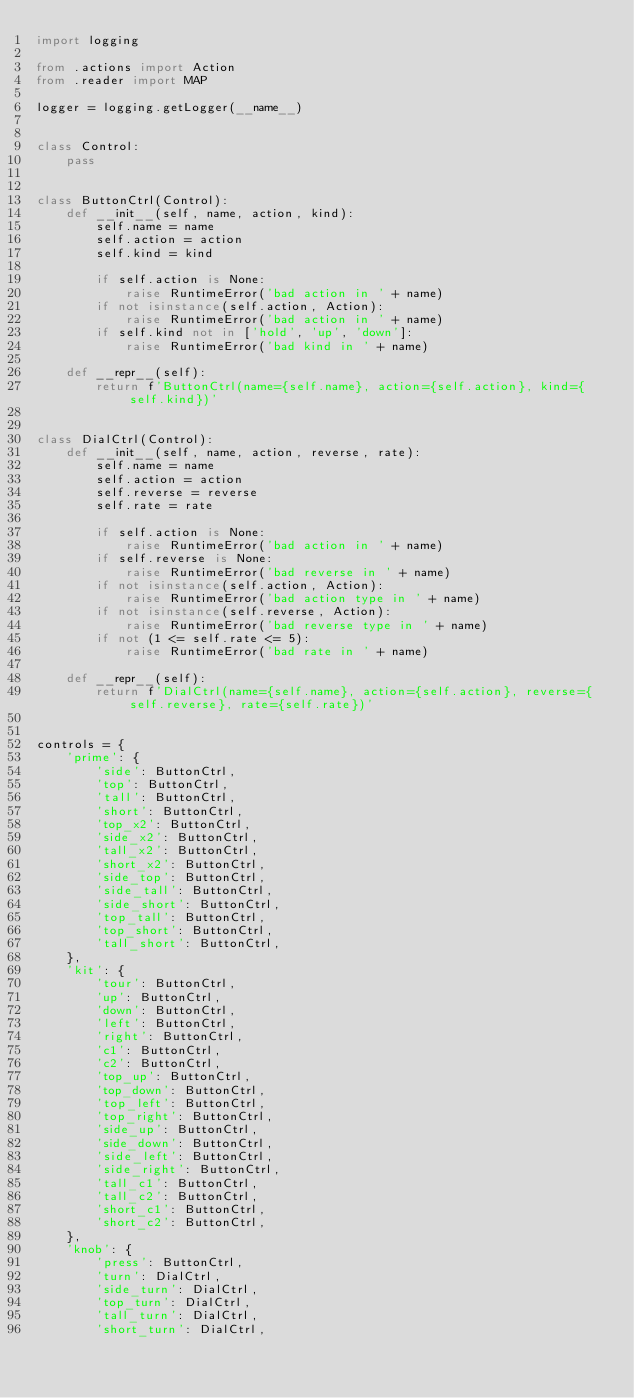Convert code to text. <code><loc_0><loc_0><loc_500><loc_500><_Python_>import logging

from .actions import Action
from .reader import MAP

logger = logging.getLogger(__name__)


class Control:
    pass


class ButtonCtrl(Control):
    def __init__(self, name, action, kind):
        self.name = name
        self.action = action
        self.kind = kind

        if self.action is None:
            raise RuntimeError('bad action in ' + name)
        if not isinstance(self.action, Action):
            raise RuntimeError('bad action in ' + name)
        if self.kind not in ['hold', 'up', 'down']:
            raise RuntimeError('bad kind in ' + name)

    def __repr__(self):
        return f'ButtonCtrl(name={self.name}, action={self.action}, kind={self.kind})'


class DialCtrl(Control):
    def __init__(self, name, action, reverse, rate):
        self.name = name
        self.action = action
        self.reverse = reverse
        self.rate = rate

        if self.action is None:
            raise RuntimeError('bad action in ' + name)
        if self.reverse is None:
            raise RuntimeError('bad reverse in ' + name)
        if not isinstance(self.action, Action):
            raise RuntimeError('bad action type in ' + name)
        if not isinstance(self.reverse, Action):
            raise RuntimeError('bad reverse type in ' + name)
        if not (1 <= self.rate <= 5):
            raise RuntimeError('bad rate in ' + name)

    def __repr__(self):
        return f'DialCtrl(name={self.name}, action={self.action}, reverse={self.reverse}, rate={self.rate})'


controls = {
    'prime': {
        'side': ButtonCtrl,
        'top': ButtonCtrl,
        'tall': ButtonCtrl,
        'short': ButtonCtrl,
        'top_x2': ButtonCtrl,
        'side_x2': ButtonCtrl,
        'tall_x2': ButtonCtrl,
        'short_x2': ButtonCtrl,
        'side_top': ButtonCtrl,
        'side_tall': ButtonCtrl,
        'side_short': ButtonCtrl,
        'top_tall': ButtonCtrl,
        'top_short': ButtonCtrl,
        'tall_short': ButtonCtrl,
    },
    'kit': {
        'tour': ButtonCtrl,
        'up': ButtonCtrl,
        'down': ButtonCtrl,
        'left': ButtonCtrl,
        'right': ButtonCtrl,
        'c1': ButtonCtrl,
        'c2': ButtonCtrl,
        'top_up': ButtonCtrl,
        'top_down': ButtonCtrl,
        'top_left': ButtonCtrl,
        'top_right': ButtonCtrl,
        'side_up': ButtonCtrl,
        'side_down': ButtonCtrl,
        'side_left': ButtonCtrl,
        'side_right': ButtonCtrl,
        'tall_c1': ButtonCtrl,
        'tall_c2': ButtonCtrl,
        'short_c1': ButtonCtrl,
        'short_c2': ButtonCtrl,
    },
    'knob': {
        'press': ButtonCtrl,
        'turn': DialCtrl,
        'side_turn': DialCtrl,
        'top_turn': DialCtrl,
        'tall_turn': DialCtrl,
        'short_turn': DialCtrl,</code> 